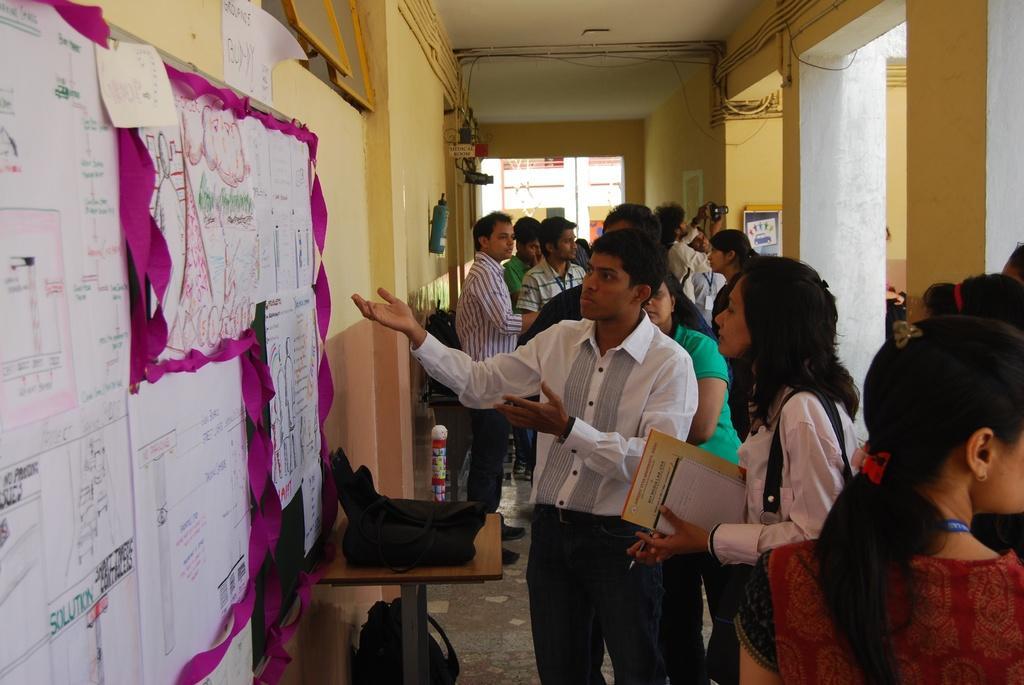In one or two sentences, can you explain what this image depicts? In the image on the right side there are many people standing. Behind them there are pillars. And also there is a wall with posters, tubes and some other things. On the left side of the image there is a wall. On the wall there is a notice board with papers. And also on the wall there is a fire extinguisher and some other things. In front of the wall there is a table with a bag. Beside the table there is a bag. In the background there is a building. 